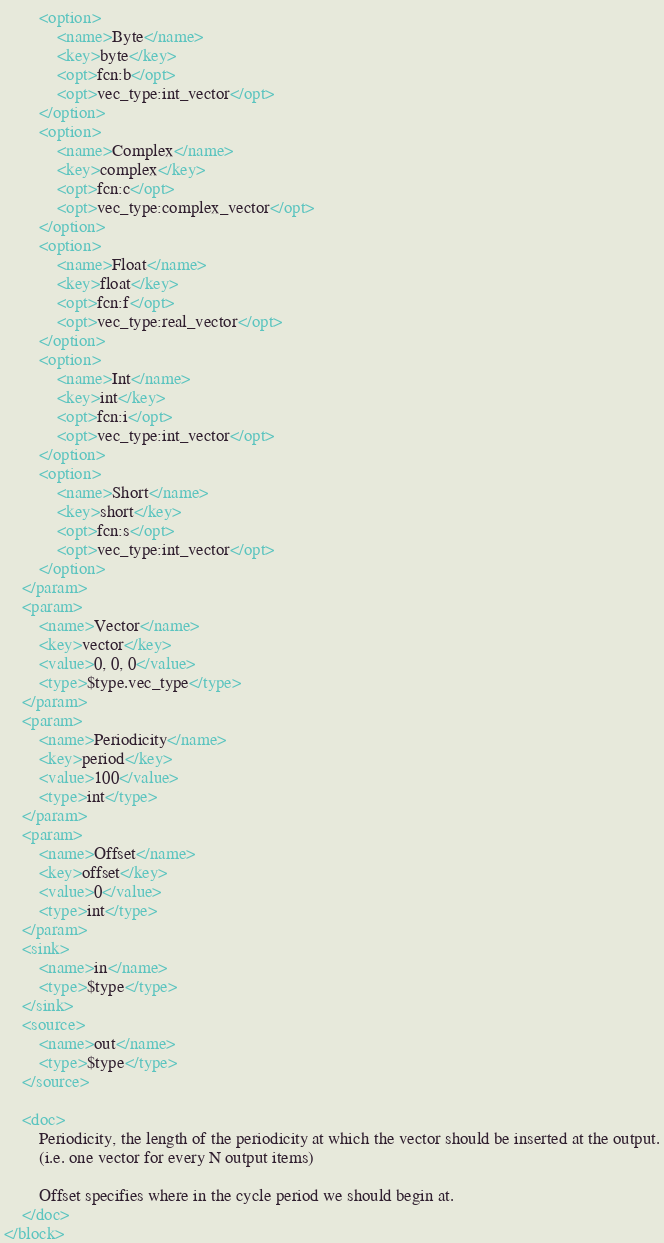Convert code to text. <code><loc_0><loc_0><loc_500><loc_500><_XML_>		<option>
			<name>Byte</name>
			<key>byte</key>
			<opt>fcn:b</opt>
			<opt>vec_type:int_vector</opt>
		</option>
		<option>
			<name>Complex</name>
			<key>complex</key>
			<opt>fcn:c</opt>
			<opt>vec_type:complex_vector</opt>
		</option>
		<option>
			<name>Float</name>
			<key>float</key>
			<opt>fcn:f</opt>
			<opt>vec_type:real_vector</opt>
		</option>
		<option>
			<name>Int</name>
			<key>int</key>
			<opt>fcn:i</opt>
			<opt>vec_type:int_vector</opt>
		</option>
		<option>
			<name>Short</name>
			<key>short</key>
			<opt>fcn:s</opt>
			<opt>vec_type:int_vector</opt>
		</option>
	</param>
	<param>
		<name>Vector</name>
		<key>vector</key>
		<value>0, 0, 0</value>
		<type>$type.vec_type</type>
	</param>
	<param>
		<name>Periodicity</name>
		<key>period</key>
		<value>100</value>
		<type>int</type>
	</param>
	<param>
		<name>Offset</name>
		<key>offset</key>
		<value>0</value>
		<type>int</type>
	</param>
	<sink>
		<name>in</name>
		<type>$type</type>
	</sink>
	<source>
		<name>out</name>
		<type>$type</type>
	</source>

    <doc>
        Periodicity, the length of the periodicity at which the vector should be inserted at the output.
        (i.e. one vector for every N output items)

        Offset specifies where in the cycle period we should begin at.
    </doc>
</block>
</code> 